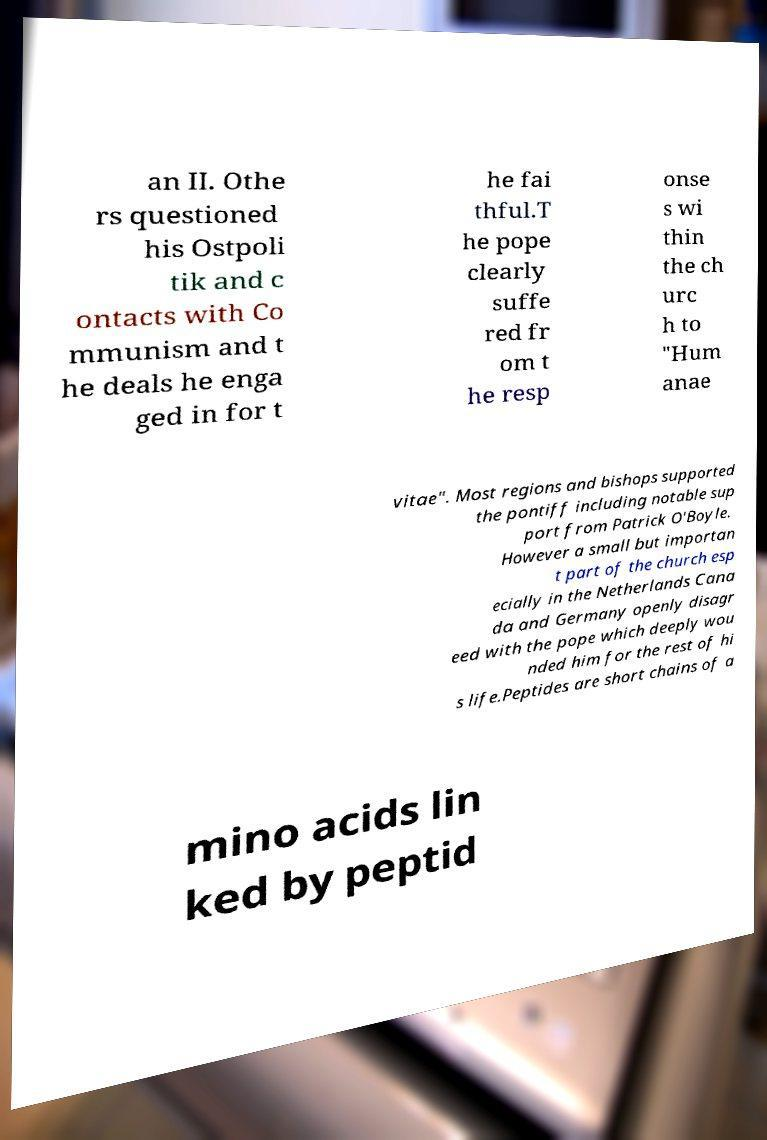Please identify and transcribe the text found in this image. an II. Othe rs questioned his Ostpoli tik and c ontacts with Co mmunism and t he deals he enga ged in for t he fai thful.T he pope clearly suffe red fr om t he resp onse s wi thin the ch urc h to "Hum anae vitae". Most regions and bishops supported the pontiff including notable sup port from Patrick O'Boyle. However a small but importan t part of the church esp ecially in the Netherlands Cana da and Germany openly disagr eed with the pope which deeply wou nded him for the rest of hi s life.Peptides are short chains of a mino acids lin ked by peptid 